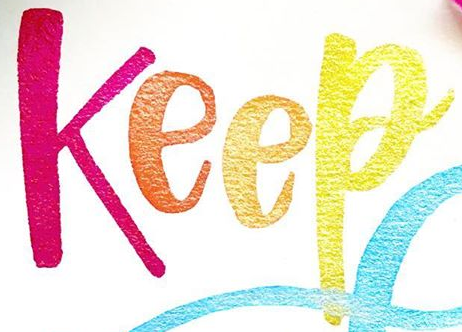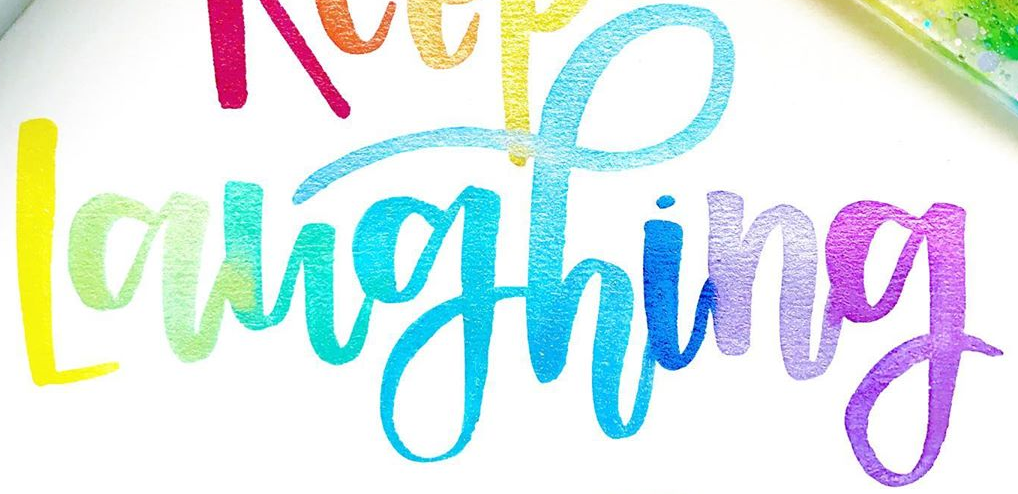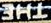What text is displayed in these images sequentially, separated by a semicolon? Keep; Laughing; THE 